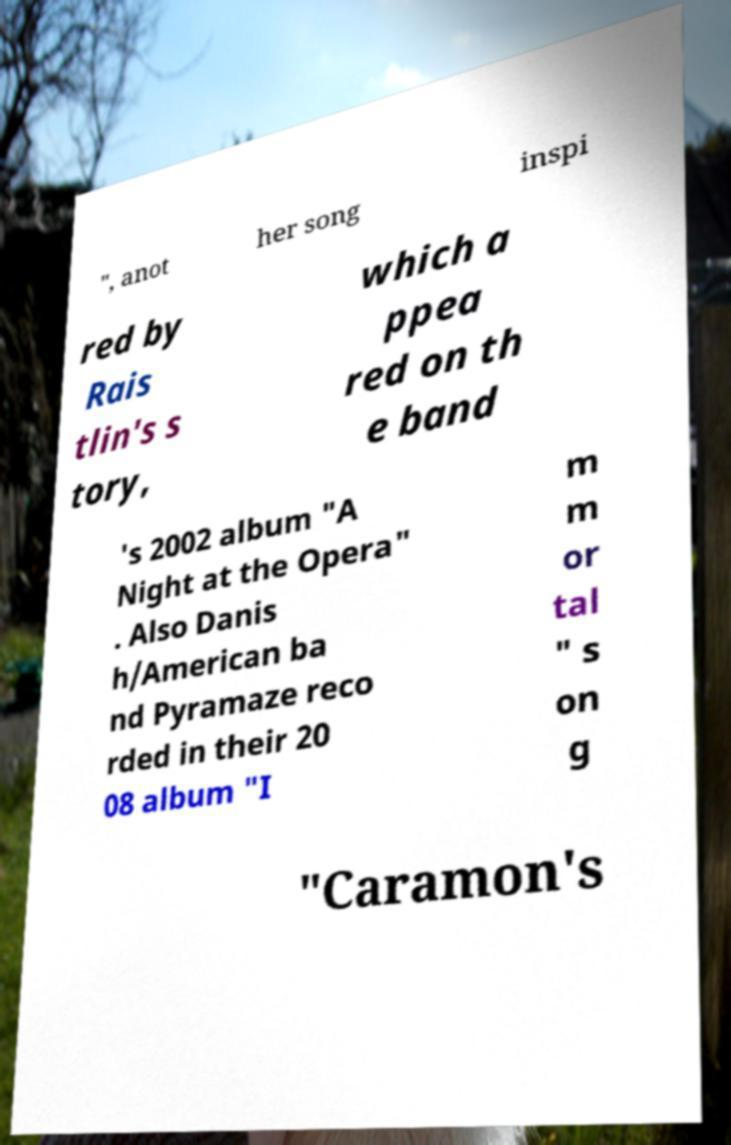Could you extract and type out the text from this image? ", anot her song inspi red by Rais tlin's s tory, which a ppea red on th e band 's 2002 album "A Night at the Opera" . Also Danis h/American ba nd Pyramaze reco rded in their 20 08 album "I m m or tal " s on g "Caramon's 